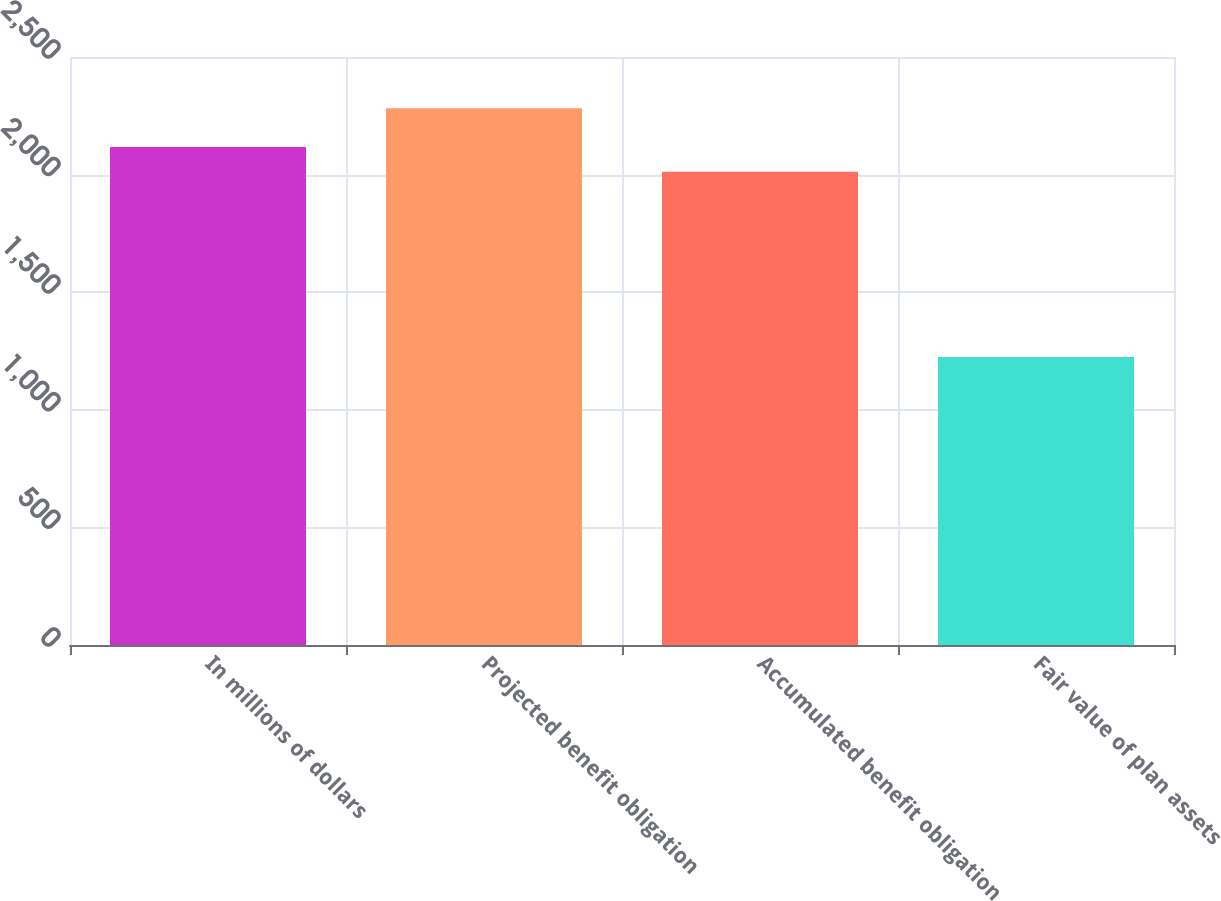Convert chart. <chart><loc_0><loc_0><loc_500><loc_500><bar_chart><fcel>In millions of dollars<fcel>Projected benefit obligation<fcel>Accumulated benefit obligation<fcel>Fair value of plan assets<nl><fcel>2117.8<fcel>2282<fcel>2012<fcel>1224<nl></chart> 